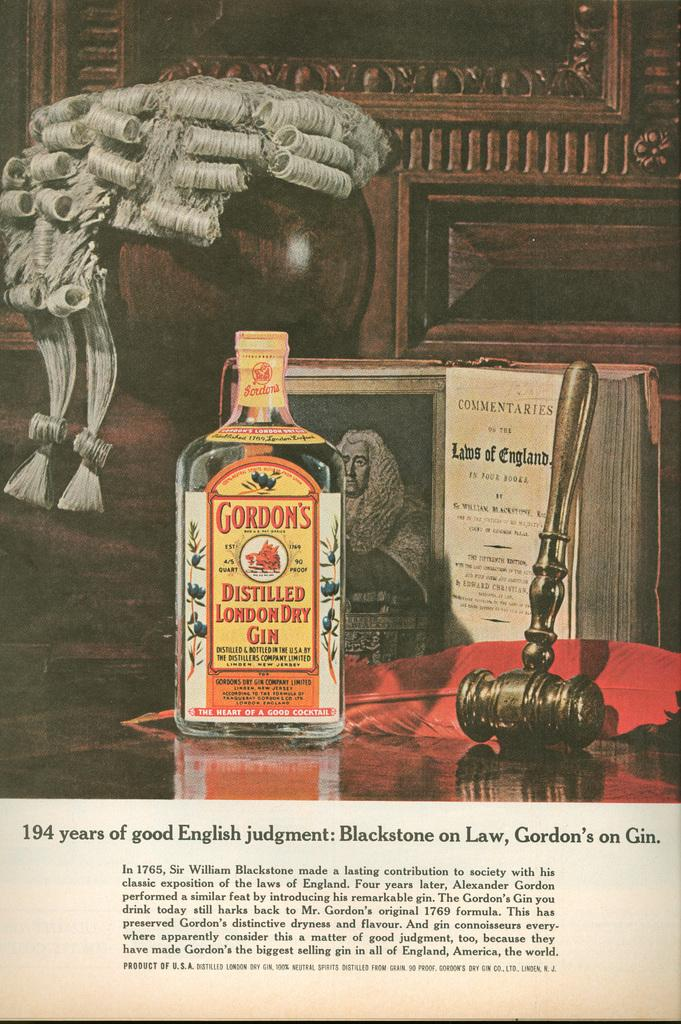<image>
Summarize the visual content of the image. A bottle of Gordon's Distilled London Dry gin on a table next to a book. 